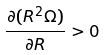Convert formula to latex. <formula><loc_0><loc_0><loc_500><loc_500>\frac { \partial ( R ^ { 2 } \Omega ) } { \partial R } > 0</formula> 